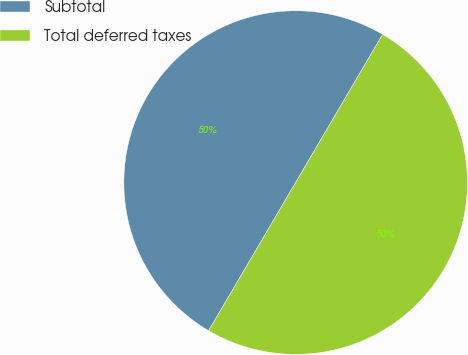<chart> <loc_0><loc_0><loc_500><loc_500><pie_chart><fcel>Subtotal<fcel>Total deferred taxes<nl><fcel>50.0%<fcel>50.0%<nl></chart> 